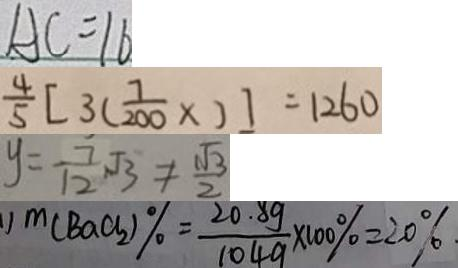<formula> <loc_0><loc_0><loc_500><loc_500>A C = 1 6 
 \frac { 4 } { 5 } [ 3 ( \frac { 7 } { 2 0 0 } \times ) ] = 1 2 6 0 
 y = \frac { 7 } { 1 2 } \sqrt { 3 } \neq \frac { \sqrt { 3 } } { 2 } 
 1 ) m ( B a C l _ { 2 } ) \% = \frac { 2 0 . 8 g } { 1 0 4 g } \times 1 0 0 \% = 2 0 \% .</formula> 